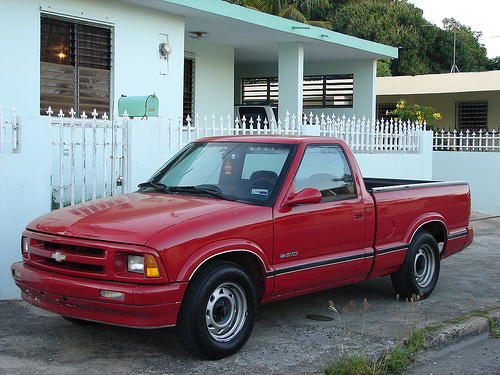<image>
Is there a home on the car? No. The home is not positioned on the car. They may be near each other, but the home is not supported by or resting on top of the car. Is the truck in front of the house? No. The truck is not in front of the house. The spatial positioning shows a different relationship between these objects. 